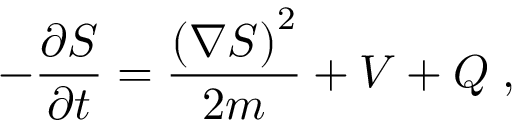<formula> <loc_0><loc_0><loc_500><loc_500>- { \frac { \partial S } { \partial t } } = { \frac { \left ( \nabla S \right ) ^ { 2 } } { 2 m } } + V + Q \, ,</formula> 